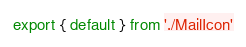<code> <loc_0><loc_0><loc_500><loc_500><_JavaScript_>export { default } from './MailIcon'
</code> 